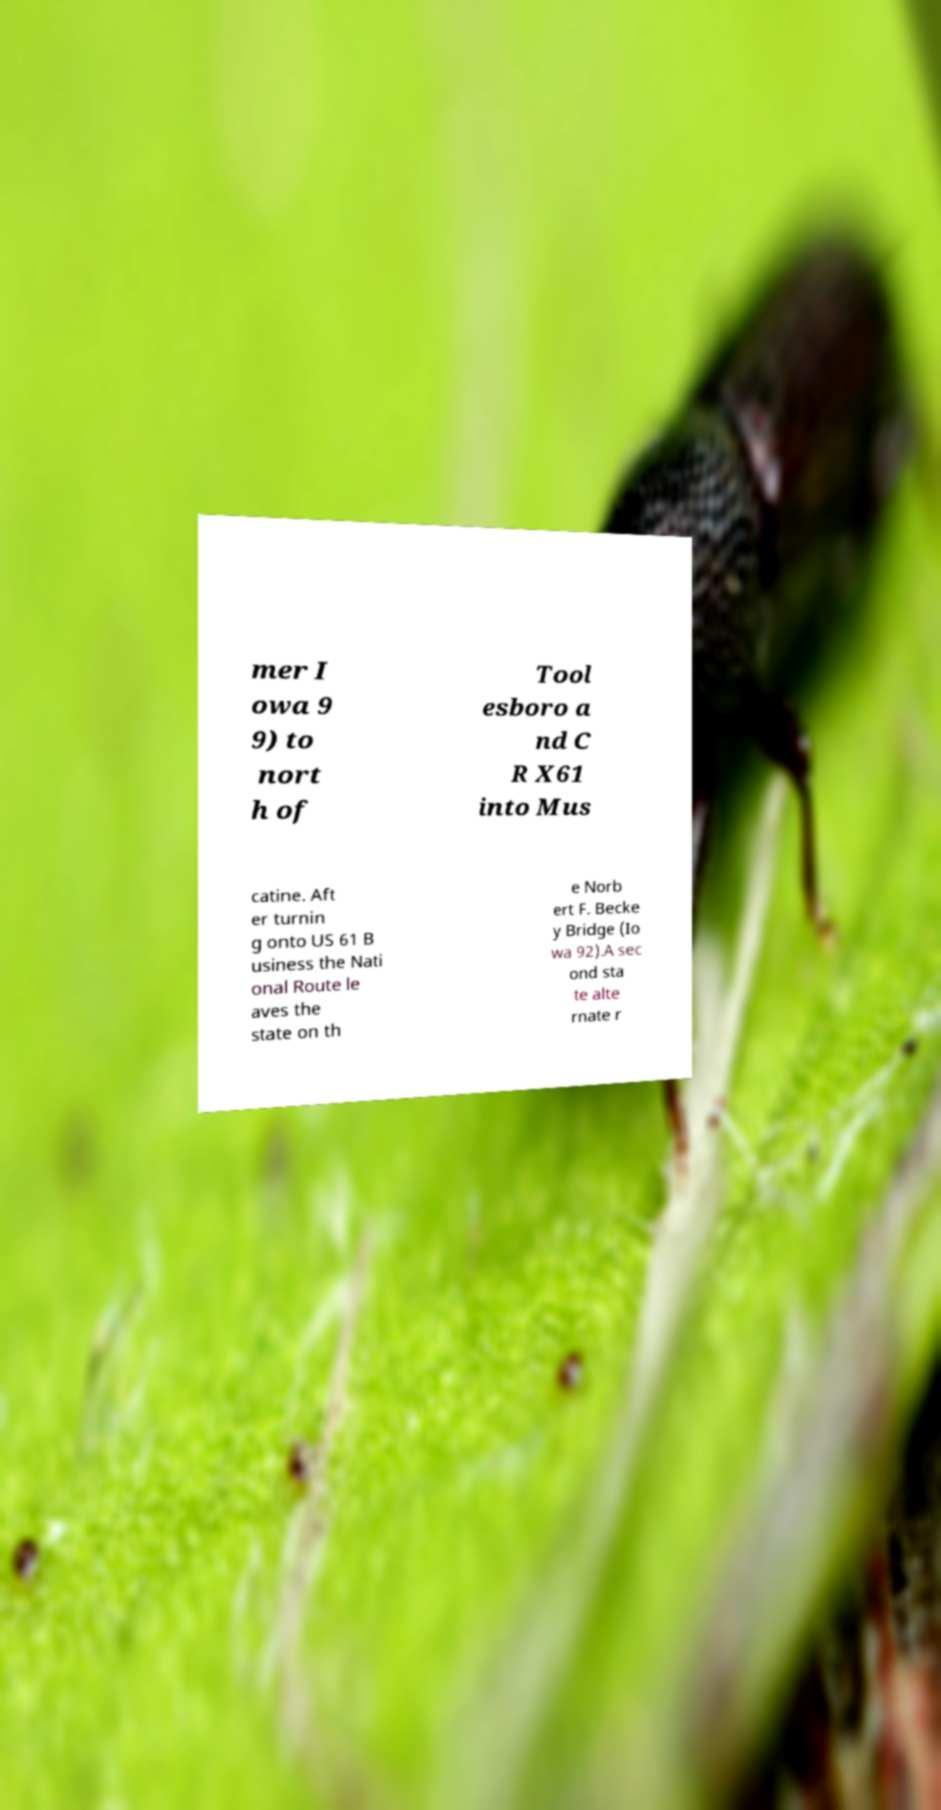Please read and relay the text visible in this image. What does it say? mer I owa 9 9) to nort h of Tool esboro a nd C R X61 into Mus catine. Aft er turnin g onto US 61 B usiness the Nati onal Route le aves the state on th e Norb ert F. Becke y Bridge (Io wa 92).A sec ond sta te alte rnate r 